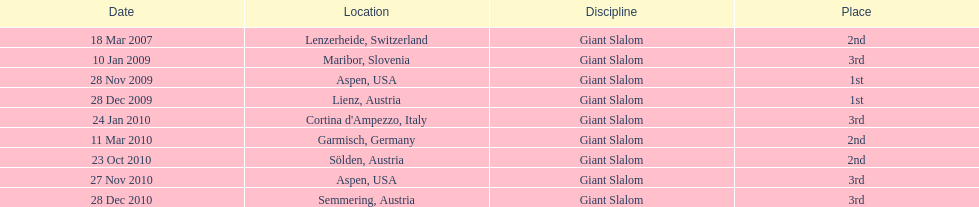The final race finishing place was not 1st but what other place? 3rd. Could you parse the entire table? {'header': ['Date', 'Location', 'Discipline', 'Place'], 'rows': [['18 Mar 2007', 'Lenzerheide, Switzerland', 'Giant Slalom', '2nd'], ['10 Jan 2009', 'Maribor, Slovenia', 'Giant Slalom', '3rd'], ['28 Nov 2009', 'Aspen, USA', 'Giant Slalom', '1st'], ['28 Dec 2009', 'Lienz, Austria', 'Giant Slalom', '1st'], ['24 Jan 2010', "Cortina d'Ampezzo, Italy", 'Giant Slalom', '3rd'], ['11 Mar 2010', 'Garmisch, Germany', 'Giant Slalom', '2nd'], ['23 Oct 2010', 'Sölden, Austria', 'Giant Slalom', '2nd'], ['27 Nov 2010', 'Aspen, USA', 'Giant Slalom', '3rd'], ['28 Dec 2010', 'Semmering, Austria', 'Giant Slalom', '3rd']]} 